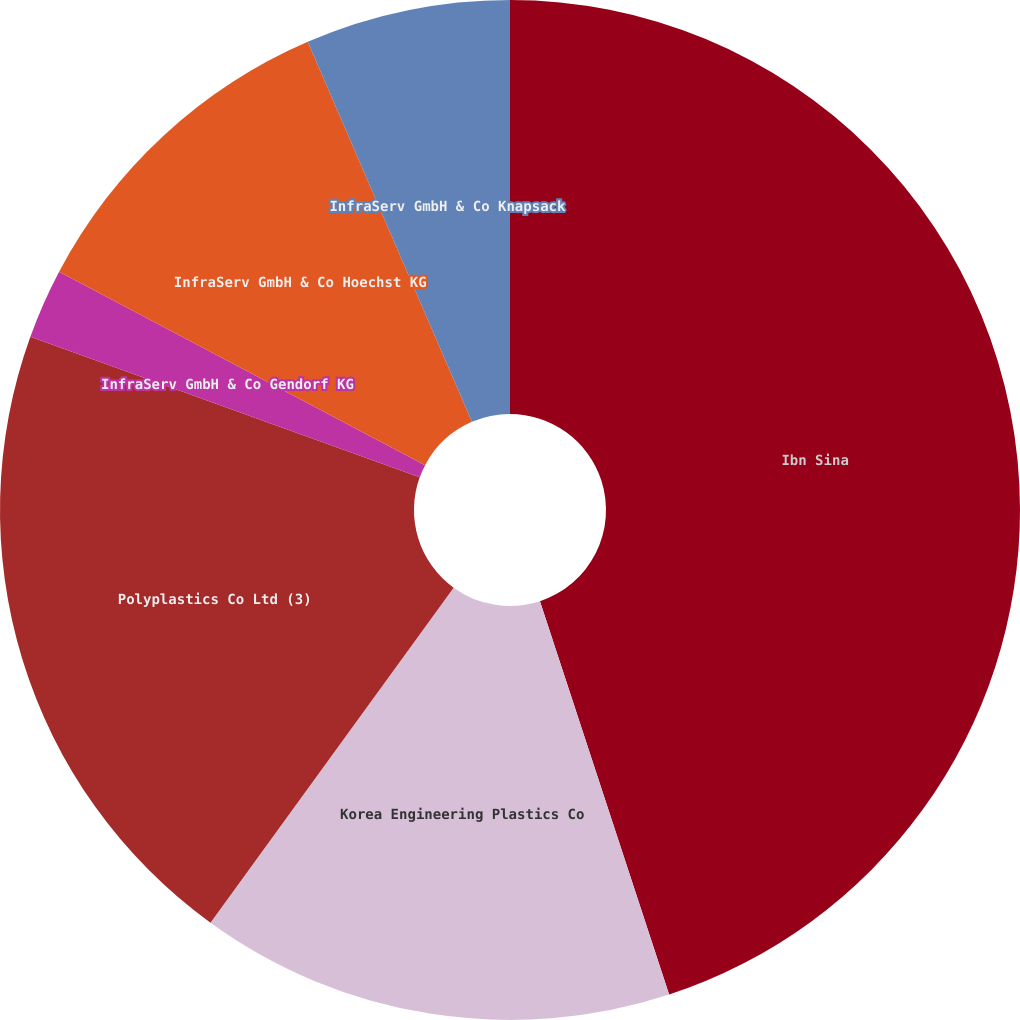Convert chart to OTSL. <chart><loc_0><loc_0><loc_500><loc_500><pie_chart><fcel>Ibn Sina<fcel>Korea Engineering Plastics Co<fcel>Polyplastics Co Ltd (3)<fcel>InfraServ GmbH & Co Gendorf KG<fcel>InfraServ GmbH & Co Hoechst KG<fcel>InfraServ GmbH & Co Knapsack<nl><fcel>44.95%<fcel>15.04%<fcel>20.53%<fcel>2.22%<fcel>10.77%<fcel>6.49%<nl></chart> 